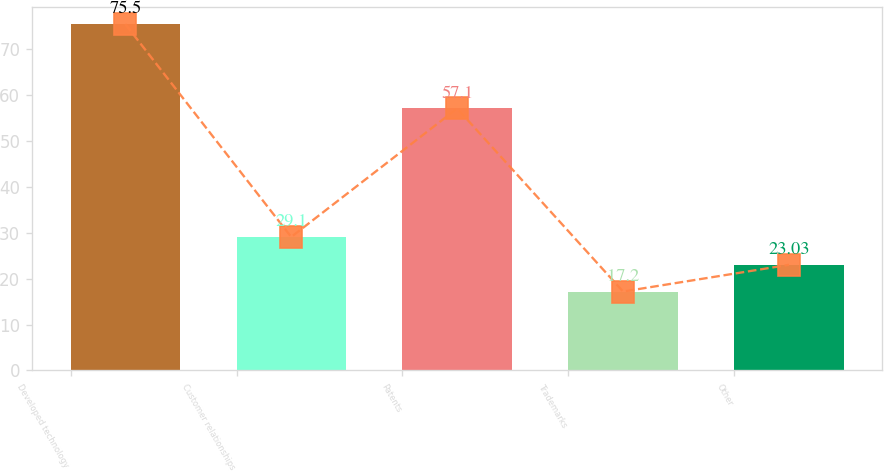<chart> <loc_0><loc_0><loc_500><loc_500><bar_chart><fcel>Developed technology<fcel>Customer relationships<fcel>Patents<fcel>Trademarks<fcel>Other<nl><fcel>75.5<fcel>29.1<fcel>57.1<fcel>17.2<fcel>23.03<nl></chart> 